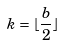<formula> <loc_0><loc_0><loc_500><loc_500>k = \lfloor \frac { b } { 2 } \rfloor</formula> 